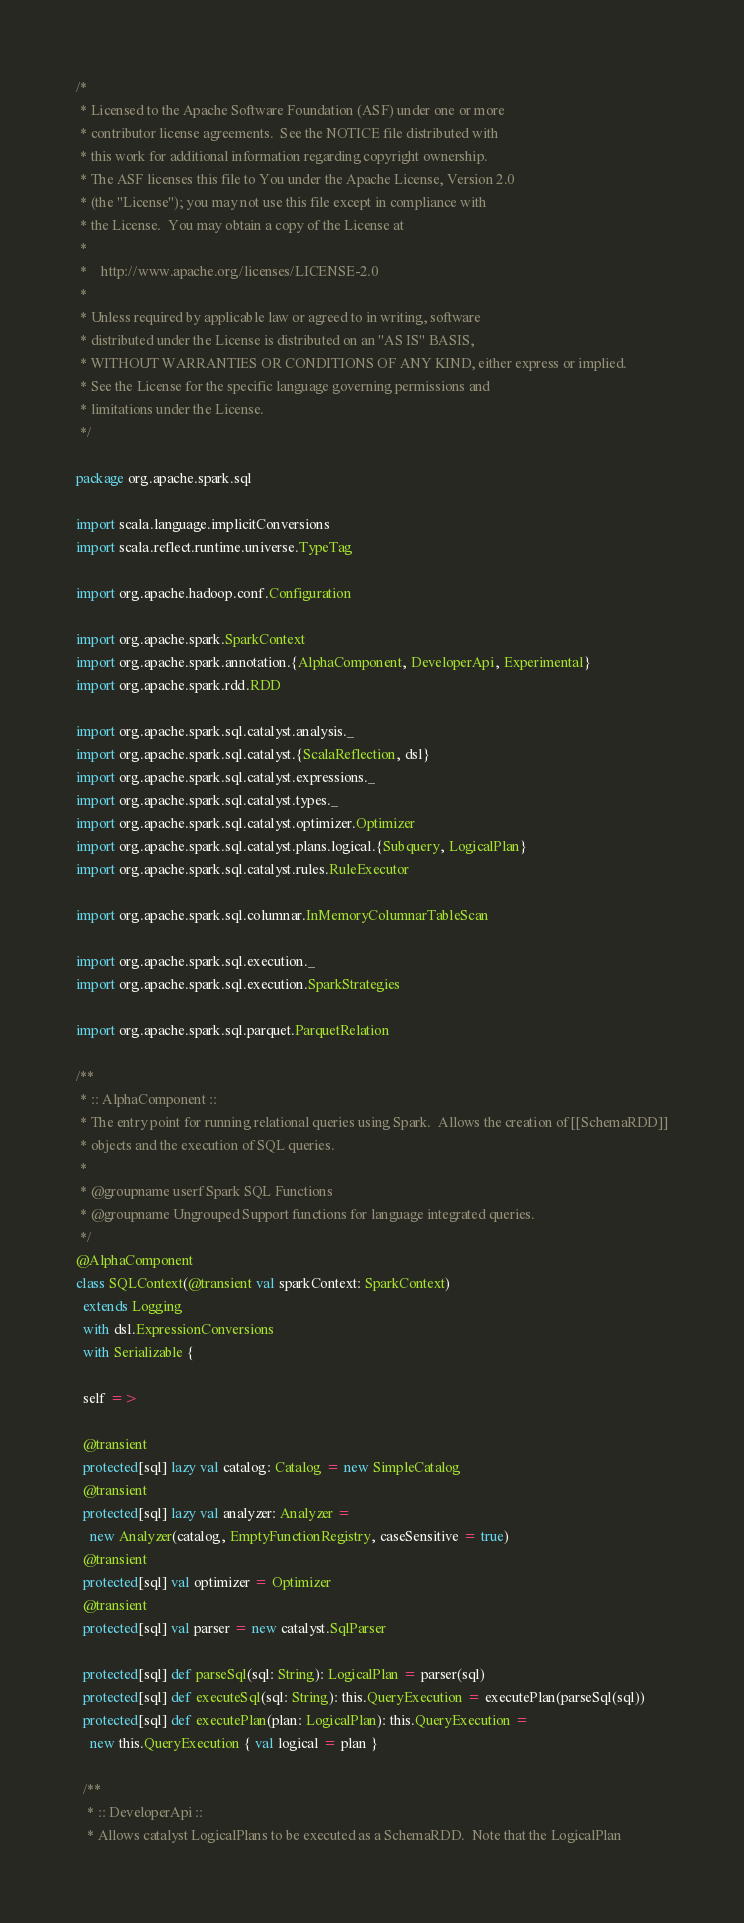<code> <loc_0><loc_0><loc_500><loc_500><_Scala_>/*
 * Licensed to the Apache Software Foundation (ASF) under one or more
 * contributor license agreements.  See the NOTICE file distributed with
 * this work for additional information regarding copyright ownership.
 * The ASF licenses this file to You under the Apache License, Version 2.0
 * (the "License"); you may not use this file except in compliance with
 * the License.  You may obtain a copy of the License at
 *
 *    http://www.apache.org/licenses/LICENSE-2.0
 *
 * Unless required by applicable law or agreed to in writing, software
 * distributed under the License is distributed on an "AS IS" BASIS,
 * WITHOUT WARRANTIES OR CONDITIONS OF ANY KIND, either express or implied.
 * See the License for the specific language governing permissions and
 * limitations under the License.
 */

package org.apache.spark.sql

import scala.language.implicitConversions
import scala.reflect.runtime.universe.TypeTag

import org.apache.hadoop.conf.Configuration

import org.apache.spark.SparkContext
import org.apache.spark.annotation.{AlphaComponent, DeveloperApi, Experimental}
import org.apache.spark.rdd.RDD

import org.apache.spark.sql.catalyst.analysis._
import org.apache.spark.sql.catalyst.{ScalaReflection, dsl}
import org.apache.spark.sql.catalyst.expressions._
import org.apache.spark.sql.catalyst.types._
import org.apache.spark.sql.catalyst.optimizer.Optimizer
import org.apache.spark.sql.catalyst.plans.logical.{Subquery, LogicalPlan}
import org.apache.spark.sql.catalyst.rules.RuleExecutor

import org.apache.spark.sql.columnar.InMemoryColumnarTableScan

import org.apache.spark.sql.execution._
import org.apache.spark.sql.execution.SparkStrategies

import org.apache.spark.sql.parquet.ParquetRelation

/**
 * :: AlphaComponent ::
 * The entry point for running relational queries using Spark.  Allows the creation of [[SchemaRDD]]
 * objects and the execution of SQL queries.
 *
 * @groupname userf Spark SQL Functions
 * @groupname Ungrouped Support functions for language integrated queries.
 */
@AlphaComponent
class SQLContext(@transient val sparkContext: SparkContext)
  extends Logging
  with dsl.ExpressionConversions
  with Serializable {

  self =>

  @transient
  protected[sql] lazy val catalog: Catalog = new SimpleCatalog
  @transient
  protected[sql] lazy val analyzer: Analyzer =
    new Analyzer(catalog, EmptyFunctionRegistry, caseSensitive = true)
  @transient
  protected[sql] val optimizer = Optimizer
  @transient
  protected[sql] val parser = new catalyst.SqlParser

  protected[sql] def parseSql(sql: String): LogicalPlan = parser(sql)
  protected[sql] def executeSql(sql: String): this.QueryExecution = executePlan(parseSql(sql))
  protected[sql] def executePlan(plan: LogicalPlan): this.QueryExecution =
    new this.QueryExecution { val logical = plan }

  /**
   * :: DeveloperApi ::
   * Allows catalyst LogicalPlans to be executed as a SchemaRDD.  Note that the LogicalPlan</code> 